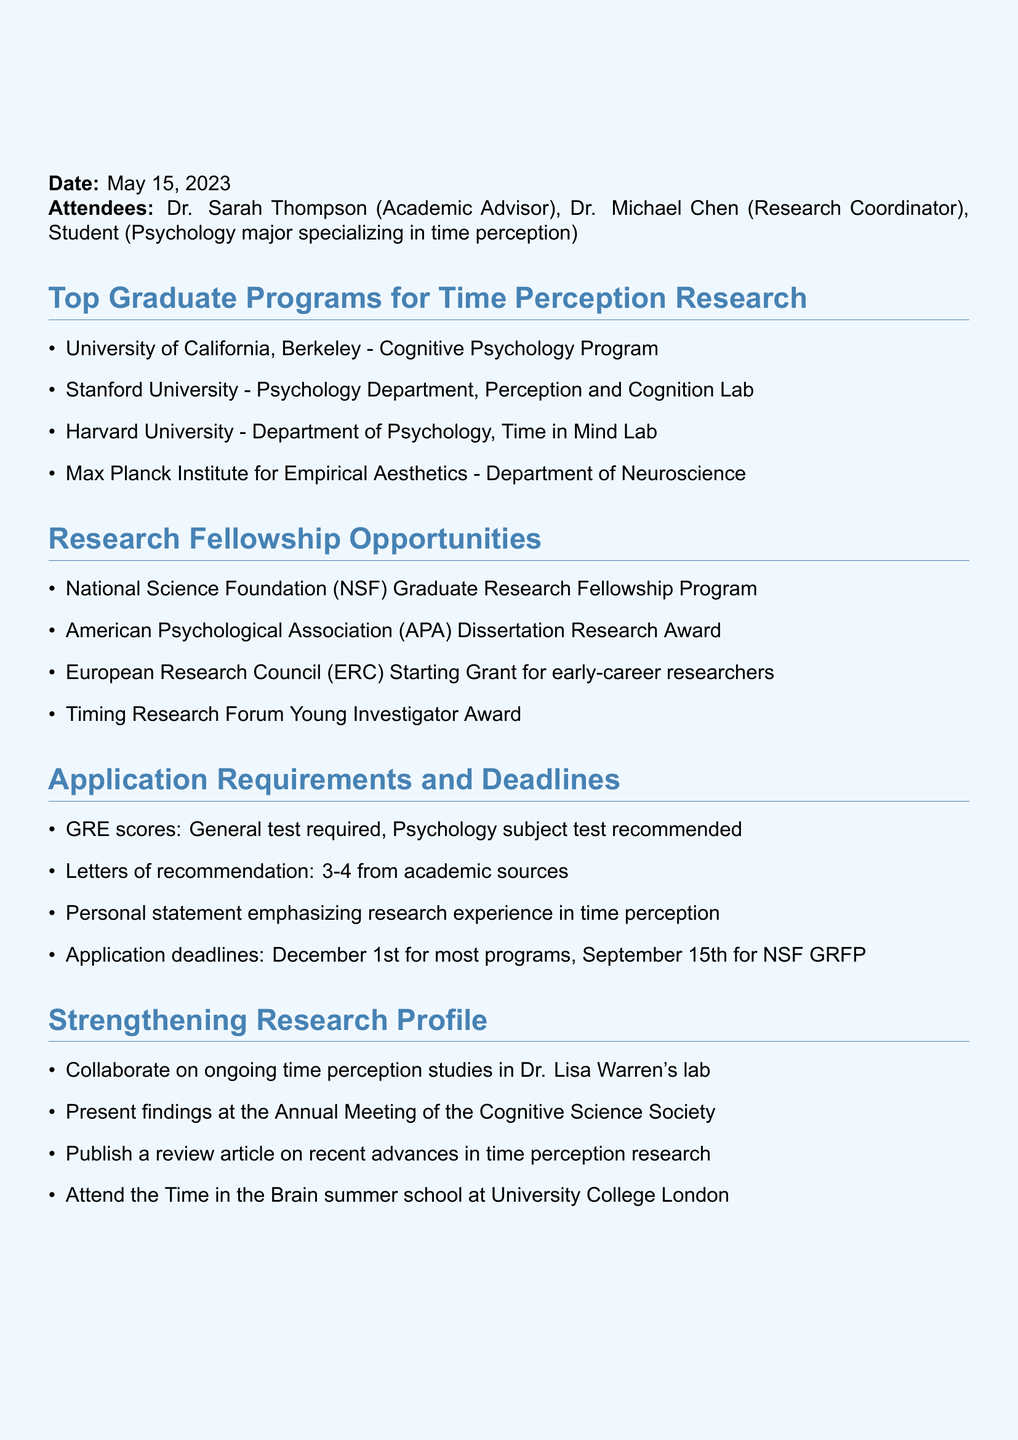What is the date of the meeting? The date of the meeting is specified at the beginning of the document.
Answer: May 15, 2023 Who is the academic advisor mentioned in the meeting? The attendees section lists Dr. Sarah Thompson as the academic advisor.
Answer: Dr. Sarah Thompson What is one of the top graduate programs for time perception research? The document lists multiple programs under the review of top graduate programs section.
Answer: University of California, Berkeley - Cognitive Psychology Program What type of research fellowship is offered by the American Psychological Association? The document mentions awards under the research fellowship opportunities section.
Answer: Dissertation Research Award What is a requirement for the application to the graduate programs? The application requirements include several items that must be fulfilled by the applicants.
Answer: GRE scores How many letters of recommendation are required? The application requirements specify the number of recommendation letters needed.
Answer: 3-4 Which lab can students collaborate with to strengthen their research profile? The document highlights specific opportunities to enhance the research profile under a dedicated section.
Answer: Dr. Lisa Warren's lab What is one of the next steps for the student? The next steps section outlines detailed action items for the student.
Answer: Schedule individual meetings with potential recommenders What is the purpose of the Time in the Brain summer school? The event listed in strengthening research profile aims to educate and facilitate research endeavors.
Answer: Summer school 